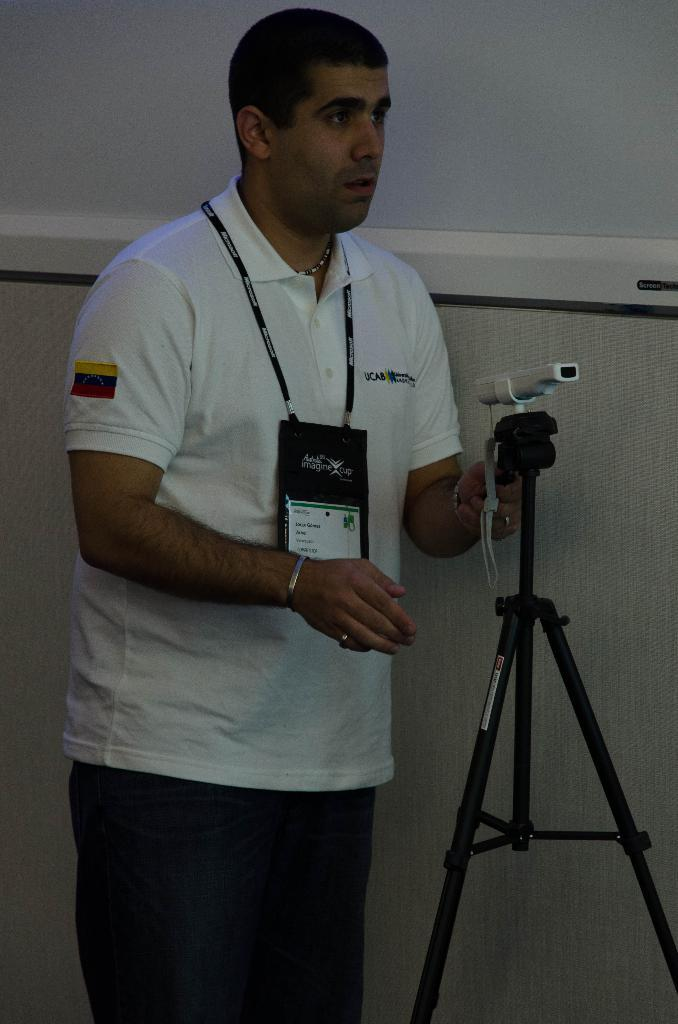Who or what is the main subject in the image? There is a person in the image. What object is in front of the person? There is a camera on a stand in front of the person. What is located beside the person? There is a wall beside the person. What type of wheel is being used for teaching in the image? There is no wheel or teaching activity present in the image. 